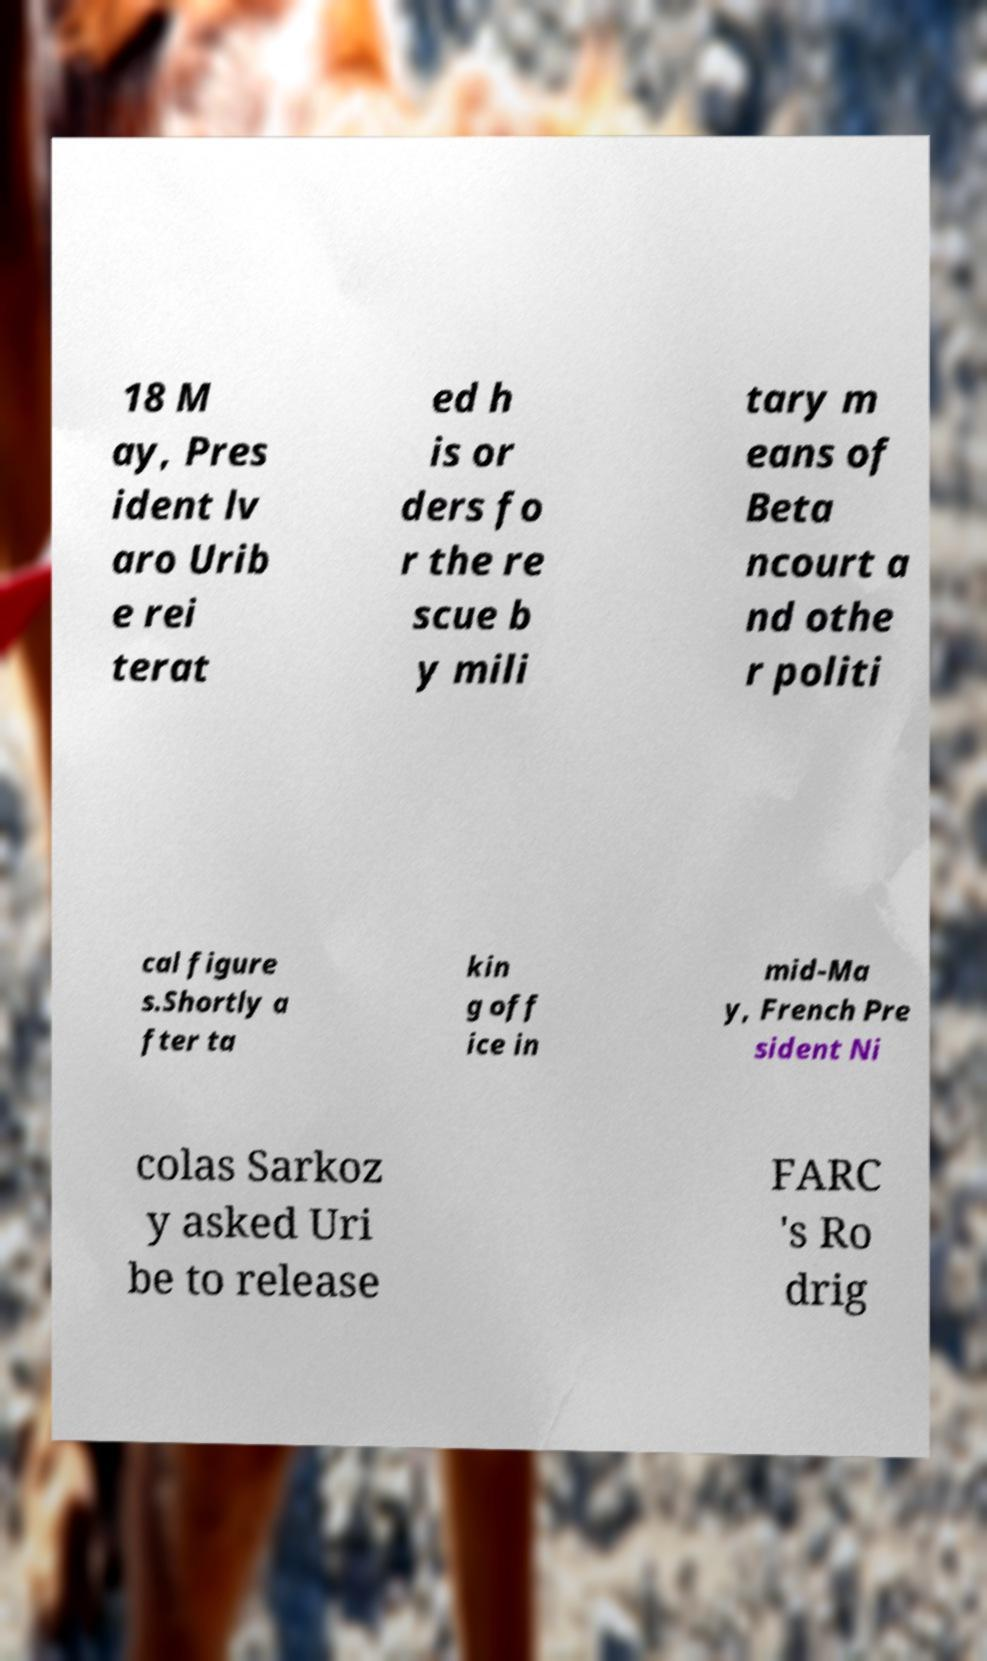There's text embedded in this image that I need extracted. Can you transcribe it verbatim? 18 M ay, Pres ident lv aro Urib e rei terat ed h is or ders fo r the re scue b y mili tary m eans of Beta ncourt a nd othe r politi cal figure s.Shortly a fter ta kin g off ice in mid-Ma y, French Pre sident Ni colas Sarkoz y asked Uri be to release FARC 's Ro drig 